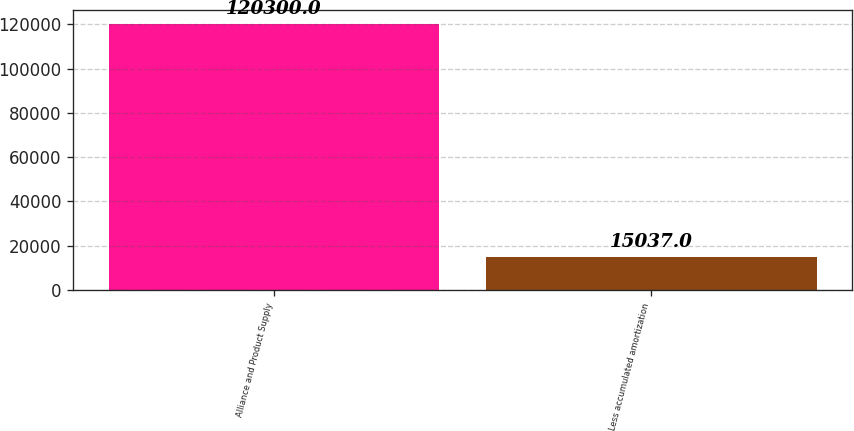<chart> <loc_0><loc_0><loc_500><loc_500><bar_chart><fcel>Alliance and Product Supply<fcel>Less accumulated amortization<nl><fcel>120300<fcel>15037<nl></chart> 